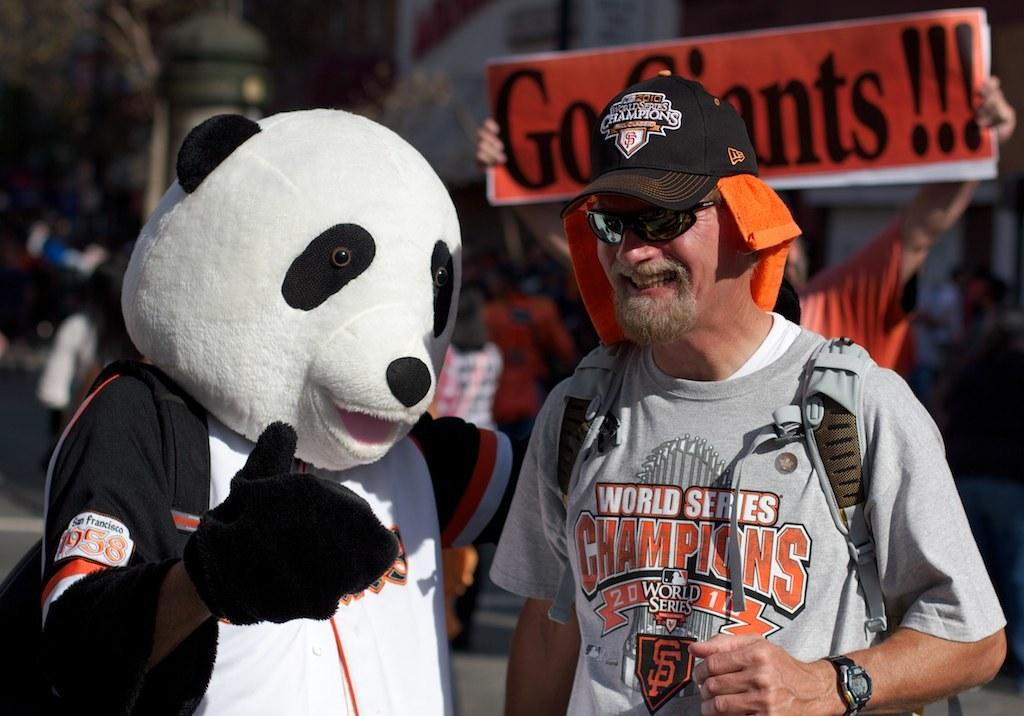Provide a one-sentence caption for the provided image. A guy wearing a World Series Champions shirt next to a mascot. 